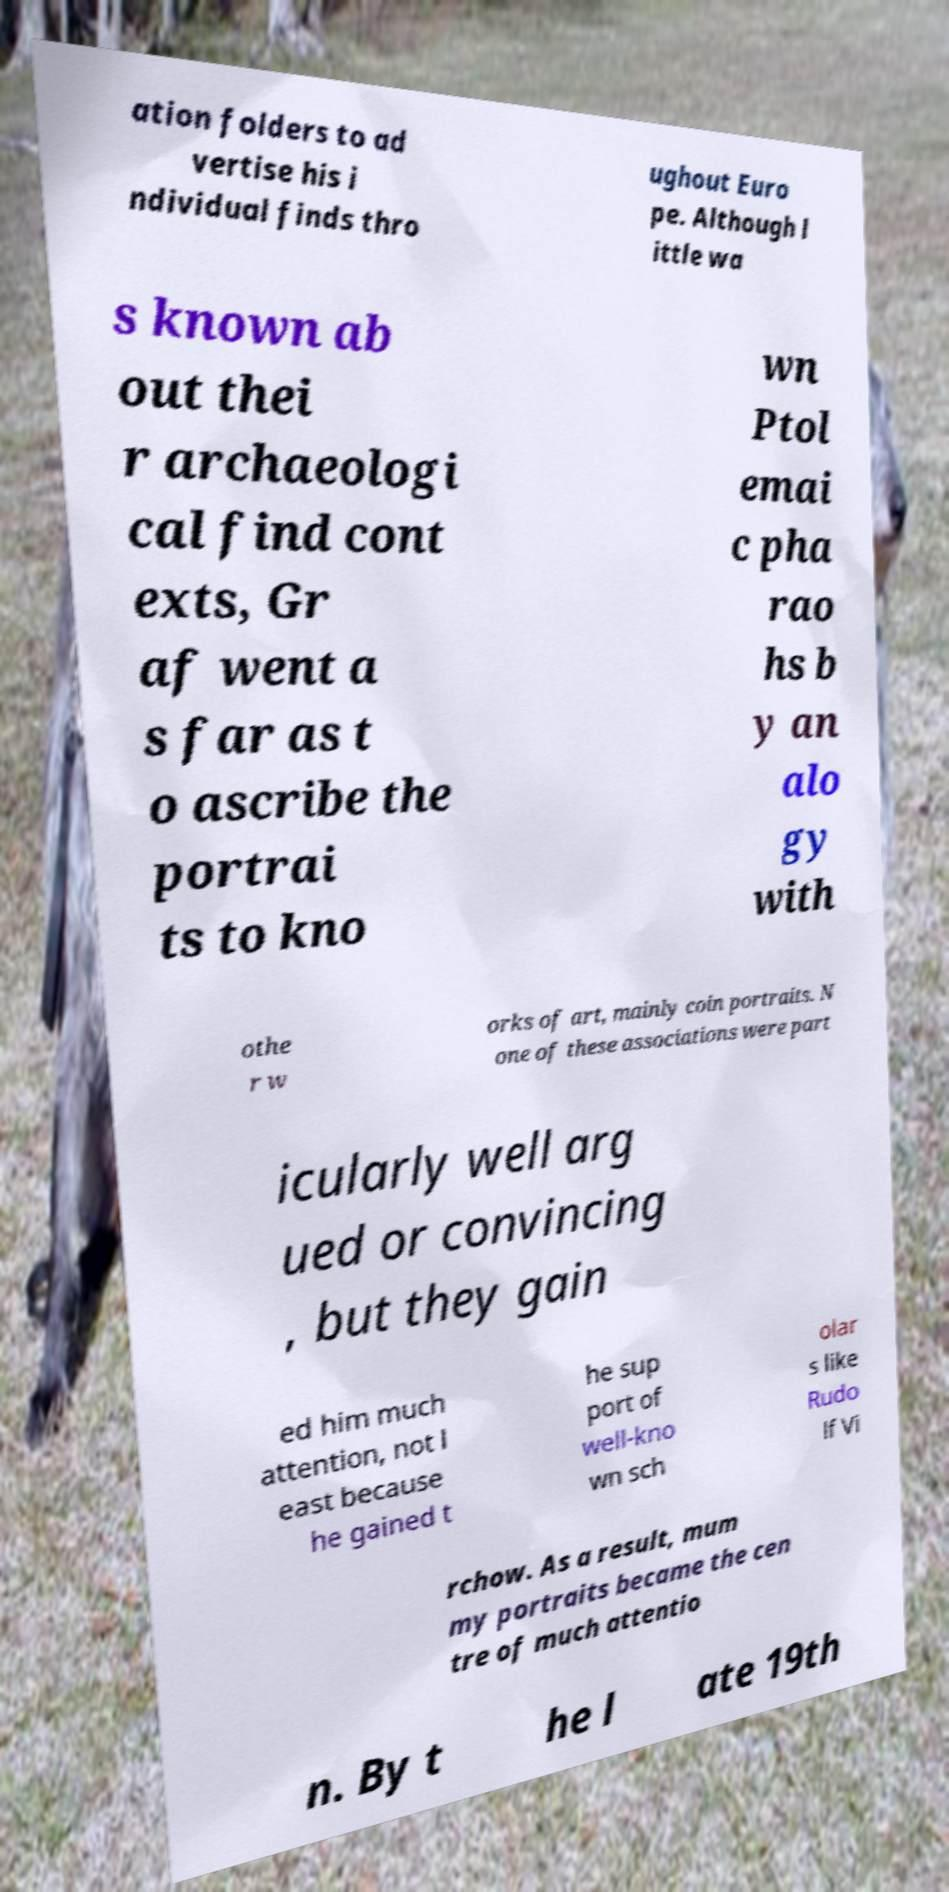Could you assist in decoding the text presented in this image and type it out clearly? ation folders to ad vertise his i ndividual finds thro ughout Euro pe. Although l ittle wa s known ab out thei r archaeologi cal find cont exts, Gr af went a s far as t o ascribe the portrai ts to kno wn Ptol emai c pha rao hs b y an alo gy with othe r w orks of art, mainly coin portraits. N one of these associations were part icularly well arg ued or convincing , but they gain ed him much attention, not l east because he gained t he sup port of well-kno wn sch olar s like Rudo lf Vi rchow. As a result, mum my portraits became the cen tre of much attentio n. By t he l ate 19th 